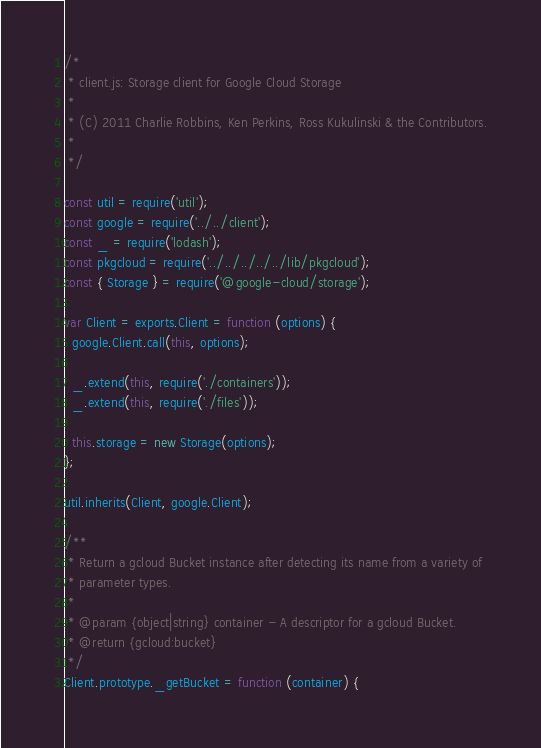<code> <loc_0><loc_0><loc_500><loc_500><_JavaScript_>/*
 * client.js: Storage client for Google Cloud Storage
 *
 * (C) 2011 Charlie Robbins, Ken Perkins, Ross Kukulinski & the Contributors.
 *
 */

const util = require('util');
const google = require('../../client');
const _ = require('lodash');
const pkgcloud = require('../../../../../lib/pkgcloud');
const { Storage } = require('@google-cloud/storage');

var Client = exports.Client = function (options) {
  google.Client.call(this, options);

  _.extend(this, require('./containers'));
  _.extend(this, require('./files'));

  this.storage = new Storage(options);
};

util.inherits(Client, google.Client);

/**
 * Return a gcloud Bucket instance after detecting its name from a variety of
 * parameter types.
 *
 * @param {object|string} container - A descriptor for a gcloud Bucket.
 * @return {gcloud:bucket}
 */
Client.prototype._getBucket = function (container) {</code> 